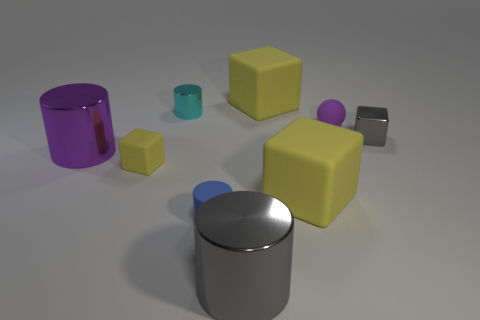There is a big object that is the same color as the matte sphere; what is its material?
Your answer should be very brief. Metal. Are there any large metal cylinders of the same color as the rubber sphere?
Your response must be concise. Yes. What number of purple rubber objects are there?
Offer a terse response. 1. What material is the gray object that is behind the gray cylinder right of the big metal cylinder left of the small yellow object?
Your answer should be very brief. Metal. Is there a large object made of the same material as the cyan cylinder?
Offer a terse response. Yes. Is the cyan cylinder made of the same material as the small blue cylinder?
Your response must be concise. No. What number of cubes are small blue objects or tiny cyan things?
Ensure brevity in your answer.  0. What color is the cylinder that is the same material as the small ball?
Ensure brevity in your answer.  Blue. Are there fewer yellow matte cubes than rubber things?
Give a very brief answer. Yes. Does the big yellow thing in front of the small gray block have the same shape as the tiny thing behind the tiny ball?
Ensure brevity in your answer.  No. 